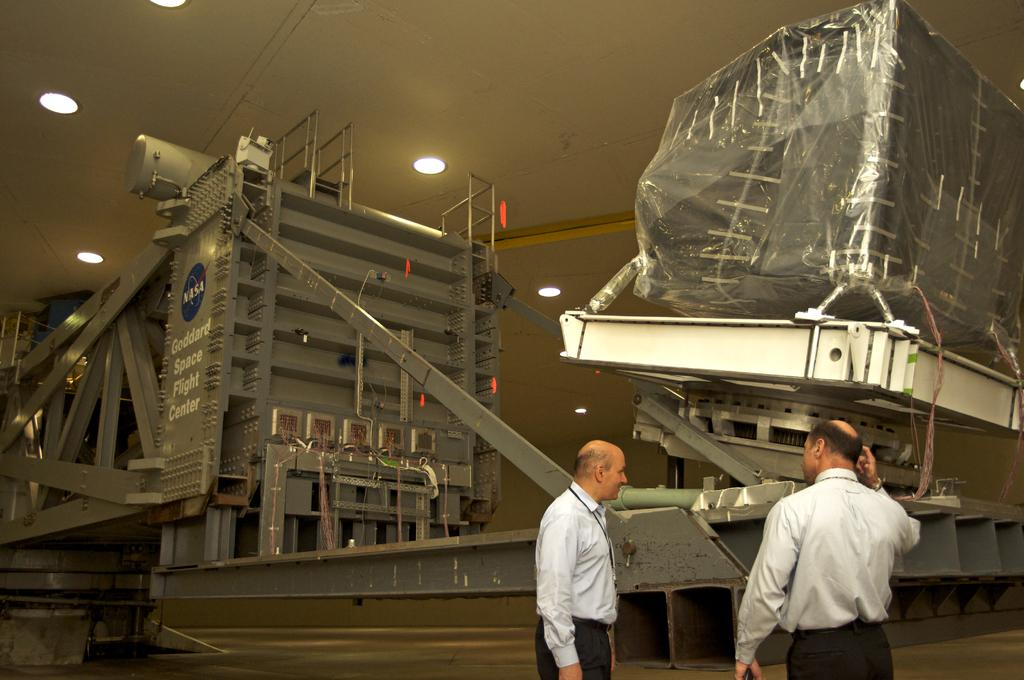How many people are present in the image? There are two persons standing in the image. What else can be seen in the image besides the people? There are machines and lights in the image. Can you describe the scene where the ants are crawling on the machines in the image? There are no ants present in the image; it only features two persons, machines, and lights. 